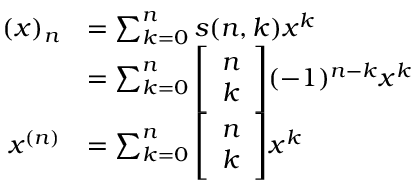<formula> <loc_0><loc_0><loc_500><loc_500>{ \begin{array} { r l } { ( x ) _ { n } } & { = \sum _ { k = 0 } ^ { n } s ( n , k ) x ^ { k } } \\ & { = \sum _ { k = 0 } ^ { n } { \left [ \begin{array} { l } { n } \\ { k } \end{array} \right ] } ( - 1 ) ^ { n - k } x ^ { k } } \\ { x ^ { ( n ) } } & { = \sum _ { k = 0 } ^ { n } { \left [ \begin{array} { l } { n } \\ { k } \end{array} \right ] } x ^ { k } } \end{array} }</formula> 